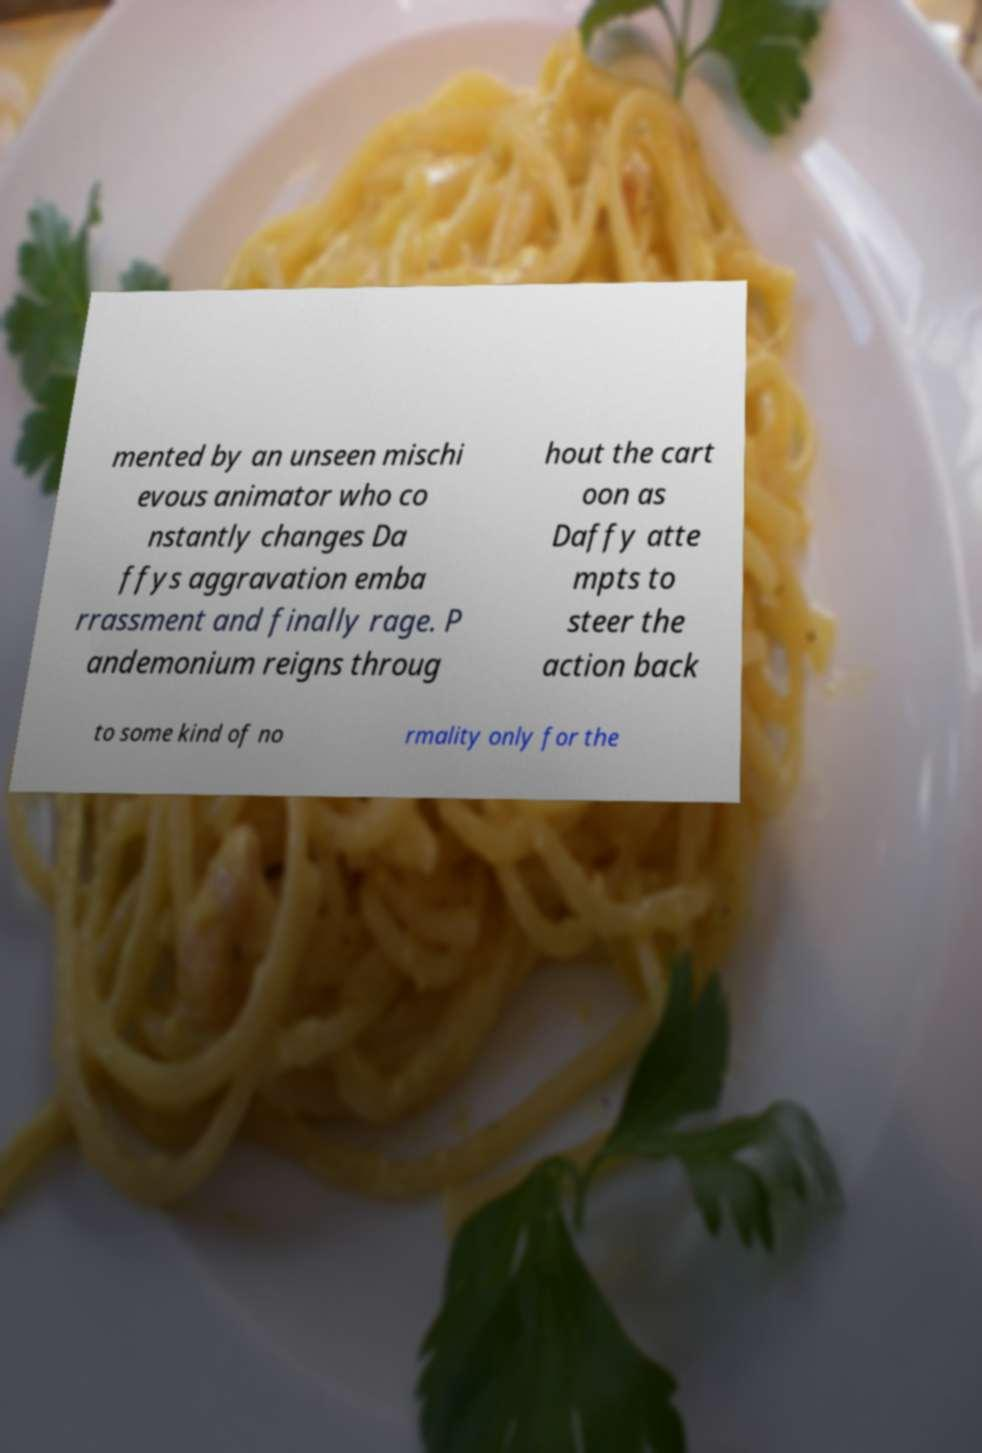Can you accurately transcribe the text from the provided image for me? mented by an unseen mischi evous animator who co nstantly changes Da ffys aggravation emba rrassment and finally rage. P andemonium reigns throug hout the cart oon as Daffy atte mpts to steer the action back to some kind of no rmality only for the 